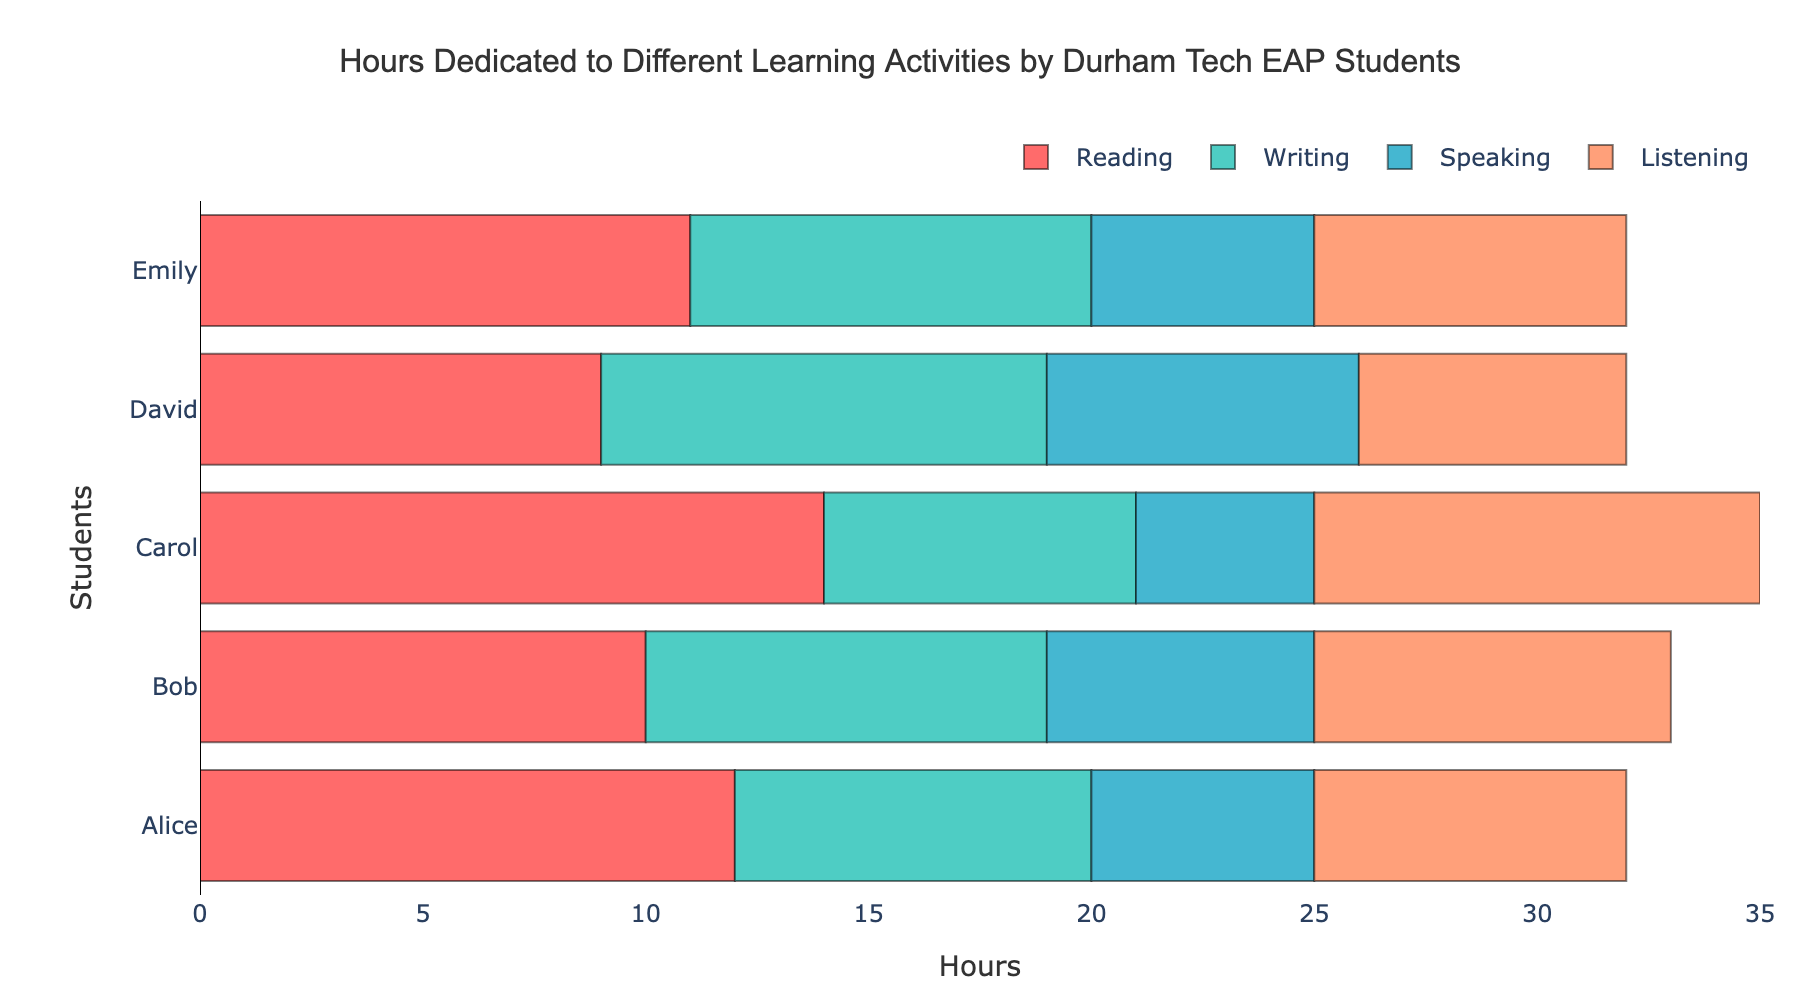What is the total number of hours Carol spent on Writing and Listening? Carol's hours for Writing and Listening are 7 and 10, respectively. Adding them, the total is 7 + 10 = 17 hours
Answer: 17 Which student dedicated the most hours to Reading? Comparing the bars for Reading for all students: Alice (12), Bob (10), Carol (14), David (9), and Emily (11). Carol has the longest bar for Reading with 14 hours
Answer: Carol Between David and Emily, who spent more hours on Speaking, and how many more hours? David spent 7 hours and Emily spent 5 hours on Speaking. The difference is 7 - 5 = 2 hours
Answer: David, 2 hours Which activity did Bob dedicate the least amount of time to, according to the bar lengths? Bob's hours: Reading (10), Writing (9), Speaking (6), Listening (8). The shortest bar is for Speaking with 6 hours
Answer: Speaking How many more hours did Alice spend on Reading compared to David? Alice spent 12 hours on Reading while David spent 9 hours. The difference is 12 - 9 = 3 hours
Answer: 3 hours What is the average time spent on Writing across all students? Writing hours: Alice (8), Bob (9), Carol (7), David (10), Emily (9). Average is (8 + 9 + 7 + 10 + 9) / 5 = 43 / 5 = 8.6
Answer: 8.6 hours Which student spent equal amounts of time on Reading and Listening? By comparing Reading and Listening hours: Alice (12, 7), Bob (10, 8), Carol (14, 10), David (9, 6), Emily (11, 7). None of the students have equal hours for both activities
Answer: None What is the combined total of hours spent on Listening by all students? Listening hours: Alice (7), Bob (8), Carol (10), David (6), Emily (7). Total is 7 + 8 + 10 + 6 + 7 = 38 hours
Answer: 38 hours If we added one more student who spent 10 hours on each activity, would the average time spent on Speaking increase or decrease? Current Speaking average: (5 + 6 + 4 + 7 + 5) / 5 = 5.4. Adding 10 hours by one more student: (5 + 6 + 4 + 7 + 5 + 10) / 6 = 37 / 6 = 6.17, which is greater than 5.4
Answer: Increase 